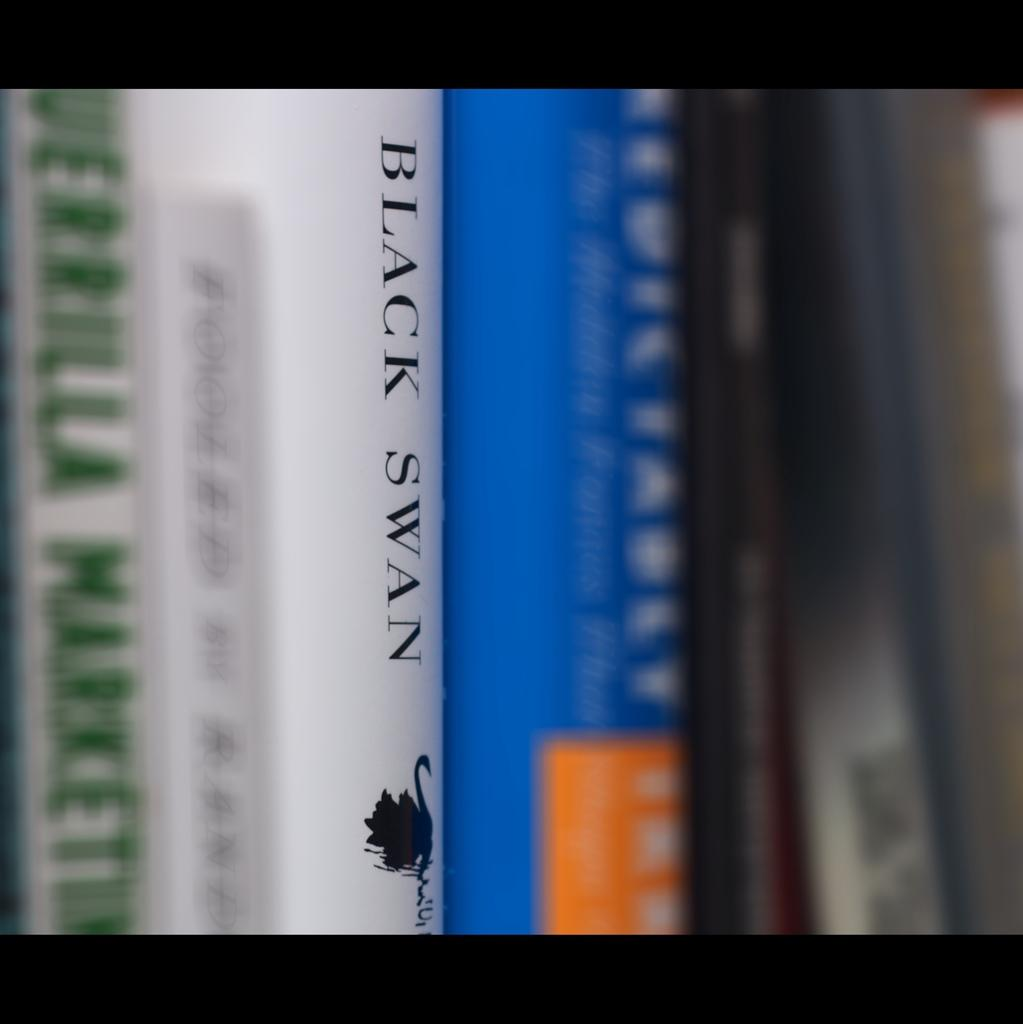<image>
Provide a brief description of the given image. Black Swan is one of the books lined up. 